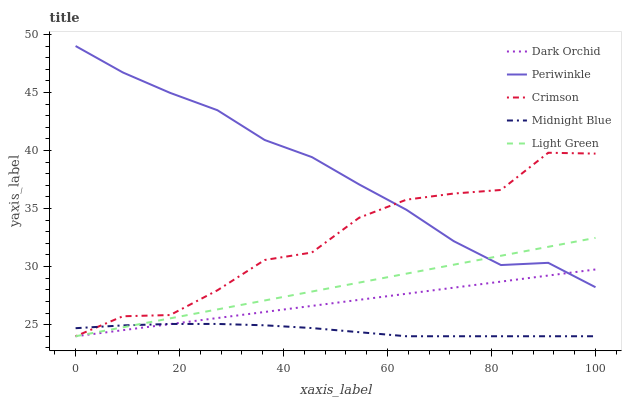Does Midnight Blue have the minimum area under the curve?
Answer yes or no. Yes. Does Periwinkle have the maximum area under the curve?
Answer yes or no. Yes. Does Light Green have the minimum area under the curve?
Answer yes or no. No. Does Light Green have the maximum area under the curve?
Answer yes or no. No. Is Dark Orchid the smoothest?
Answer yes or no. Yes. Is Crimson the roughest?
Answer yes or no. Yes. Is Light Green the smoothest?
Answer yes or no. No. Is Light Green the roughest?
Answer yes or no. No. Does Crimson have the lowest value?
Answer yes or no. Yes. Does Periwinkle have the lowest value?
Answer yes or no. No. Does Periwinkle have the highest value?
Answer yes or no. Yes. Does Light Green have the highest value?
Answer yes or no. No. Is Midnight Blue less than Periwinkle?
Answer yes or no. Yes. Is Periwinkle greater than Midnight Blue?
Answer yes or no. Yes. Does Light Green intersect Periwinkle?
Answer yes or no. Yes. Is Light Green less than Periwinkle?
Answer yes or no. No. Is Light Green greater than Periwinkle?
Answer yes or no. No. Does Midnight Blue intersect Periwinkle?
Answer yes or no. No. 